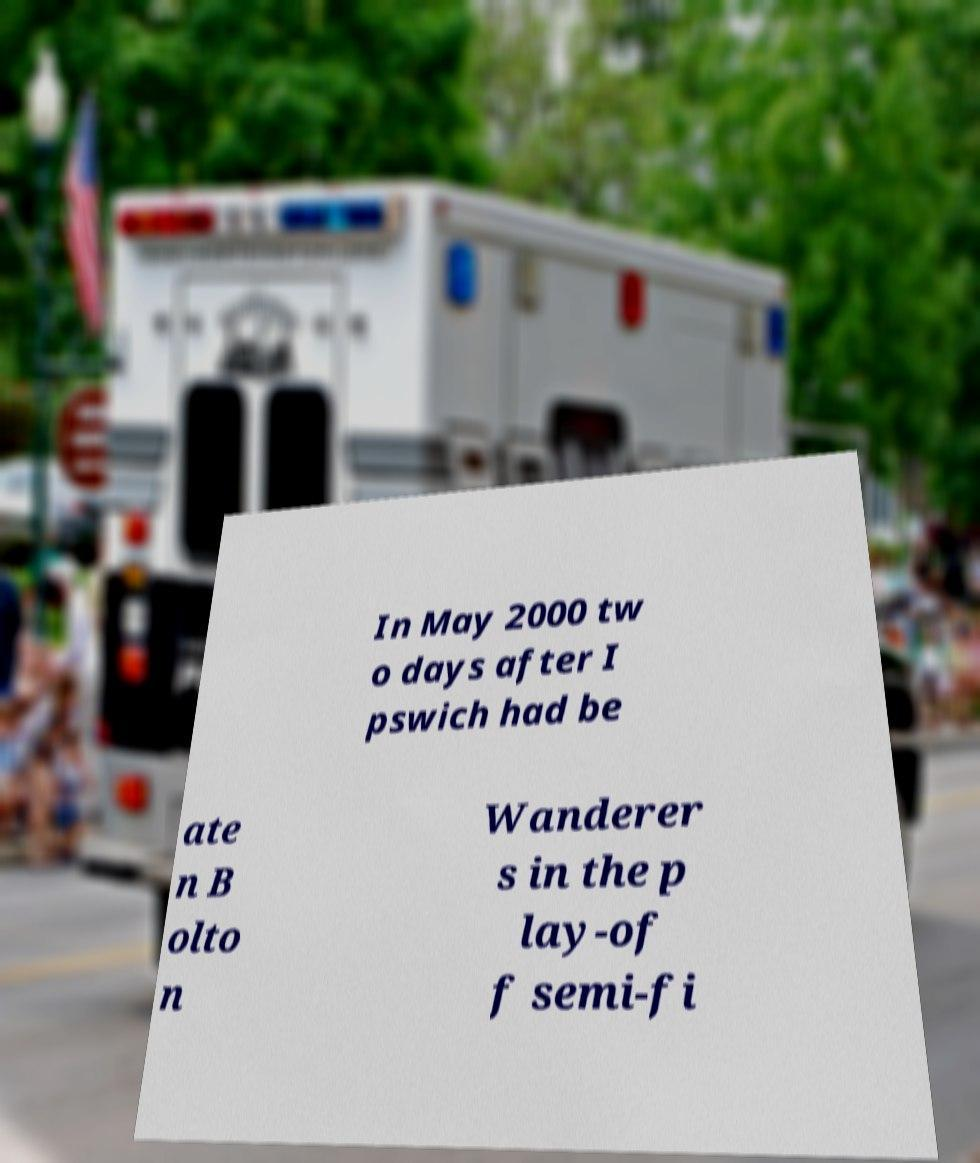Can you accurately transcribe the text from the provided image for me? In May 2000 tw o days after I pswich had be ate n B olto n Wanderer s in the p lay-of f semi-fi 